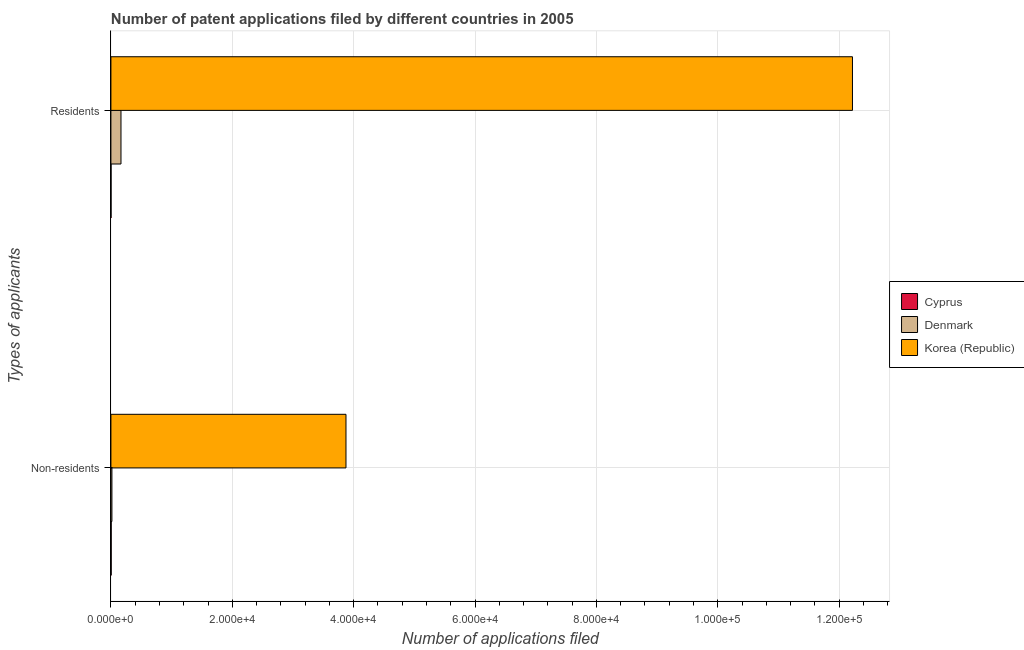How many different coloured bars are there?
Make the answer very short. 3. How many groups of bars are there?
Your answer should be very brief. 2. Are the number of bars per tick equal to the number of legend labels?
Offer a terse response. Yes. What is the label of the 1st group of bars from the top?
Offer a very short reply. Residents. What is the number of patent applications by residents in Denmark?
Make the answer very short. 1658. Across all countries, what is the maximum number of patent applications by non residents?
Offer a terse response. 3.87e+04. Across all countries, what is the minimum number of patent applications by residents?
Your answer should be compact. 20. In which country was the number of patent applications by non residents minimum?
Provide a short and direct response. Cyprus. What is the total number of patent applications by non residents in the graph?
Your answer should be compact. 3.89e+04. What is the difference between the number of patent applications by residents in Korea (Republic) and that in Denmark?
Your answer should be compact. 1.21e+05. What is the difference between the number of patent applications by residents in Cyprus and the number of patent applications by non residents in Denmark?
Ensure brevity in your answer.  -145. What is the average number of patent applications by non residents per country?
Your response must be concise. 1.30e+04. What is the difference between the number of patent applications by non residents and number of patent applications by residents in Denmark?
Ensure brevity in your answer.  -1493. In how many countries, is the number of patent applications by residents greater than 8000 ?
Provide a succinct answer. 1. What is the ratio of the number of patent applications by non residents in Denmark to that in Cyprus?
Your response must be concise. 3.75. How many countries are there in the graph?
Provide a succinct answer. 3. Does the graph contain any zero values?
Ensure brevity in your answer.  No. What is the title of the graph?
Offer a very short reply. Number of patent applications filed by different countries in 2005. What is the label or title of the X-axis?
Your answer should be very brief. Number of applications filed. What is the label or title of the Y-axis?
Your response must be concise. Types of applicants. What is the Number of applications filed in Denmark in Non-residents?
Ensure brevity in your answer.  165. What is the Number of applications filed of Korea (Republic) in Non-residents?
Offer a very short reply. 3.87e+04. What is the Number of applications filed in Cyprus in Residents?
Offer a terse response. 20. What is the Number of applications filed of Denmark in Residents?
Provide a short and direct response. 1658. What is the Number of applications filed in Korea (Republic) in Residents?
Your response must be concise. 1.22e+05. Across all Types of applicants, what is the maximum Number of applications filed of Denmark?
Your answer should be very brief. 1658. Across all Types of applicants, what is the maximum Number of applications filed of Korea (Republic)?
Your response must be concise. 1.22e+05. Across all Types of applicants, what is the minimum Number of applications filed in Denmark?
Make the answer very short. 165. Across all Types of applicants, what is the minimum Number of applications filed of Korea (Republic)?
Your answer should be compact. 3.87e+04. What is the total Number of applications filed of Denmark in the graph?
Your answer should be compact. 1823. What is the total Number of applications filed of Korea (Republic) in the graph?
Ensure brevity in your answer.  1.61e+05. What is the difference between the Number of applications filed of Cyprus in Non-residents and that in Residents?
Offer a very short reply. 24. What is the difference between the Number of applications filed in Denmark in Non-residents and that in Residents?
Provide a short and direct response. -1493. What is the difference between the Number of applications filed in Korea (Republic) in Non-residents and that in Residents?
Give a very brief answer. -8.35e+04. What is the difference between the Number of applications filed in Cyprus in Non-residents and the Number of applications filed in Denmark in Residents?
Ensure brevity in your answer.  -1614. What is the difference between the Number of applications filed in Cyprus in Non-residents and the Number of applications filed in Korea (Republic) in Residents?
Keep it short and to the point. -1.22e+05. What is the difference between the Number of applications filed of Denmark in Non-residents and the Number of applications filed of Korea (Republic) in Residents?
Give a very brief answer. -1.22e+05. What is the average Number of applications filed in Denmark per Types of applicants?
Your answer should be compact. 911.5. What is the average Number of applications filed in Korea (Republic) per Types of applicants?
Make the answer very short. 8.05e+04. What is the difference between the Number of applications filed of Cyprus and Number of applications filed of Denmark in Non-residents?
Keep it short and to the point. -121. What is the difference between the Number of applications filed of Cyprus and Number of applications filed of Korea (Republic) in Non-residents?
Provide a short and direct response. -3.87e+04. What is the difference between the Number of applications filed of Denmark and Number of applications filed of Korea (Republic) in Non-residents?
Make the answer very short. -3.86e+04. What is the difference between the Number of applications filed in Cyprus and Number of applications filed in Denmark in Residents?
Provide a succinct answer. -1638. What is the difference between the Number of applications filed in Cyprus and Number of applications filed in Korea (Republic) in Residents?
Your response must be concise. -1.22e+05. What is the difference between the Number of applications filed of Denmark and Number of applications filed of Korea (Republic) in Residents?
Keep it short and to the point. -1.21e+05. What is the ratio of the Number of applications filed of Cyprus in Non-residents to that in Residents?
Keep it short and to the point. 2.2. What is the ratio of the Number of applications filed in Denmark in Non-residents to that in Residents?
Provide a short and direct response. 0.1. What is the ratio of the Number of applications filed in Korea (Republic) in Non-residents to that in Residents?
Offer a very short reply. 0.32. What is the difference between the highest and the second highest Number of applications filed in Denmark?
Make the answer very short. 1493. What is the difference between the highest and the second highest Number of applications filed of Korea (Republic)?
Make the answer very short. 8.35e+04. What is the difference between the highest and the lowest Number of applications filed in Denmark?
Your answer should be compact. 1493. What is the difference between the highest and the lowest Number of applications filed of Korea (Republic)?
Your response must be concise. 8.35e+04. 